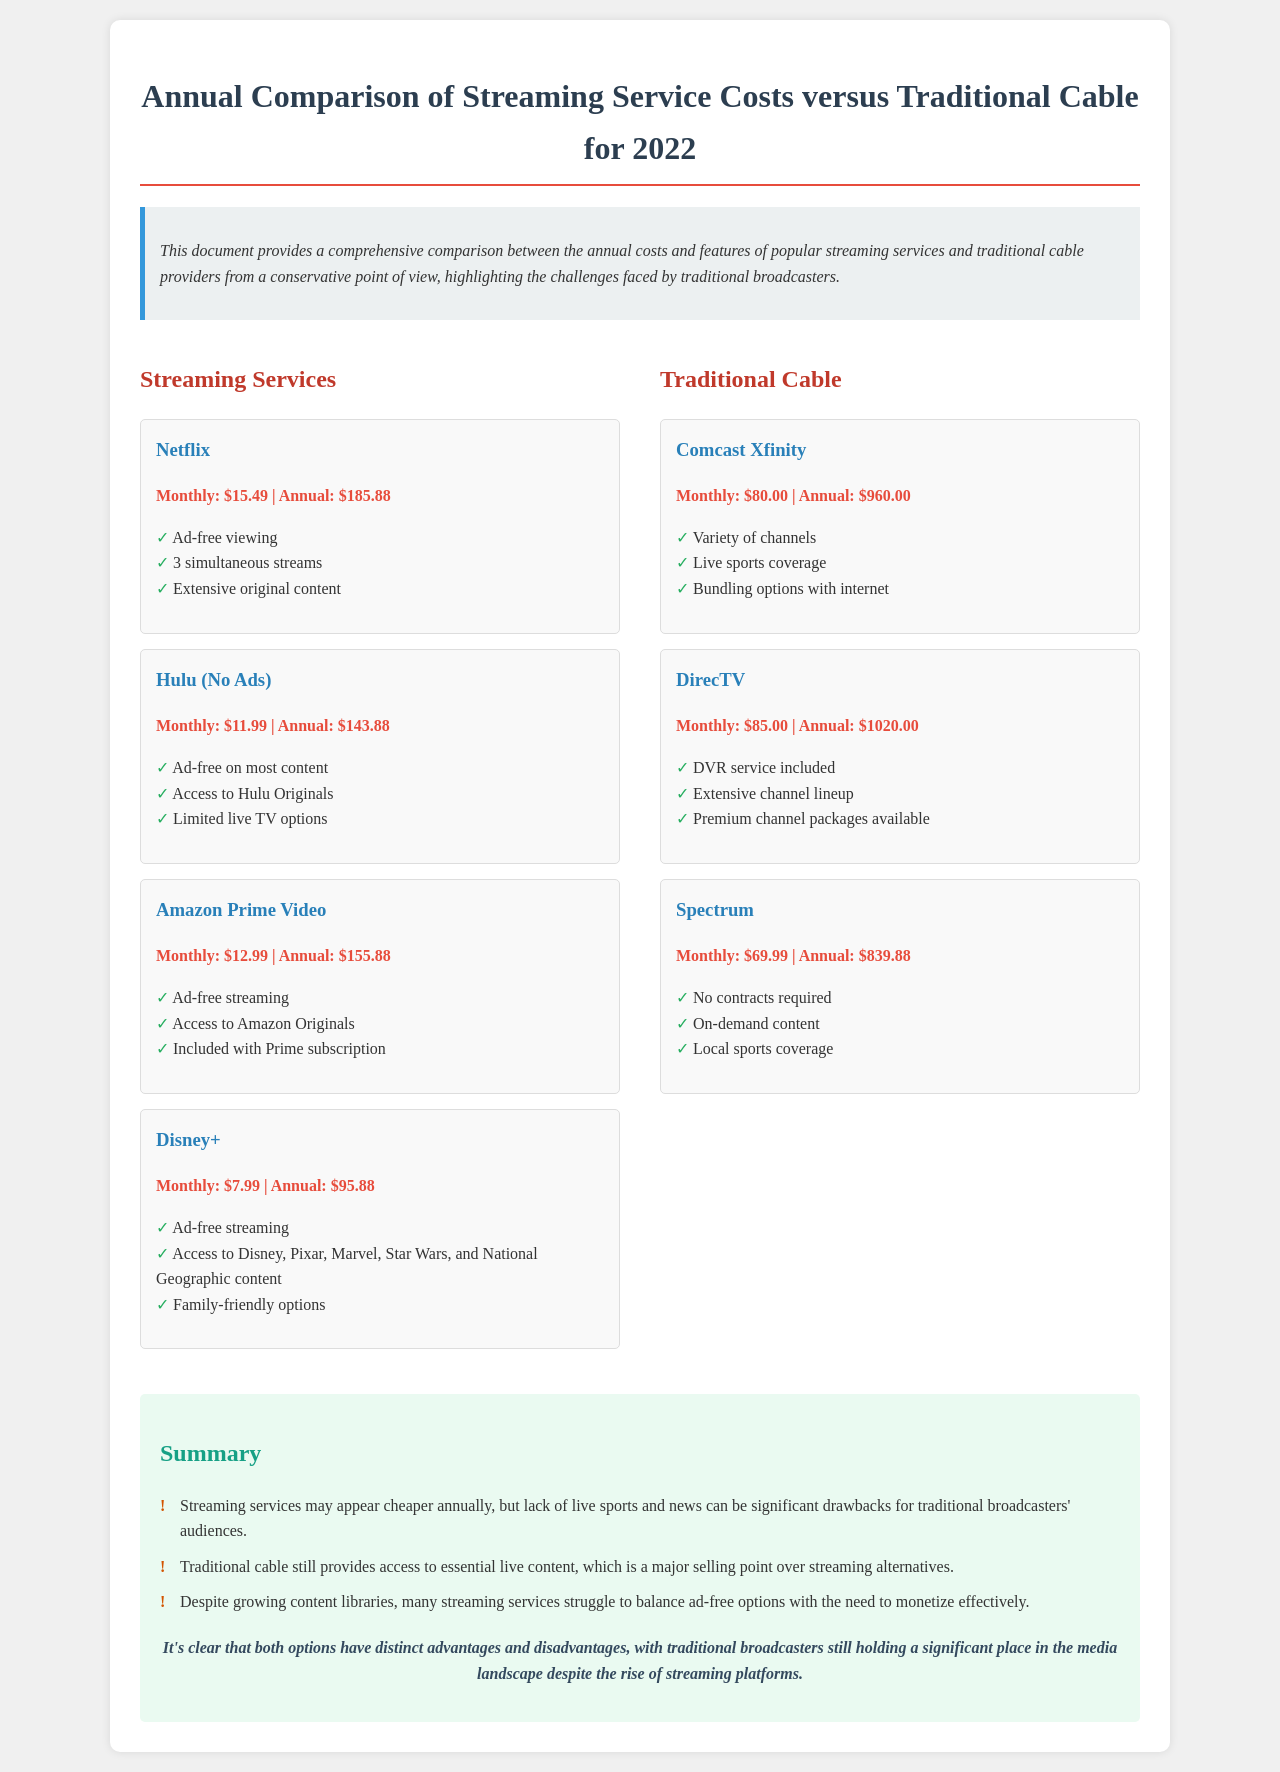What is the annual cost of Netflix? The annual cost of Netflix is stated in the document as $185.88.
Answer: $185.88 How many simultaneous streams does Hulu (No Ads) offer? The document indicates that Hulu (No Ads) offers 3 simultaneous streams.
Answer: 3 What is the monthly cost of Disney+? The monthly cost of Disney+ is provided in the document as $7.99.
Answer: $7.99 Which traditional cable service has the highest annual cost? The document lists DirecTV as having the highest annual cost of $1020.00.
Answer: $1020.00 What is a key advantage of traditional cable over streaming services according to the summary? The key advantage noted is access to essential live content.
Answer: Live content Which streaming service includes access to Amazon Originals? The document specifies that Amazon Prime Video includes access to Amazon Originals.
Answer: Amazon Prime Video What feature is unique to Comcast Xfinity among the listed traditional cable services? The document highlights that Comcast Xfinity offers bundling options with internet.
Answer: Bundling options with internet How many features does Hulu (No Ads) have listed in the document? The document shows that Hulu (No Ads) lists three features.
Answer: 3 What is the main conclusion about the media landscape mentioned in the conclusion? The conclusion states that traditional broadcasters still hold a significant place in the media landscape.
Answer: Significant place 